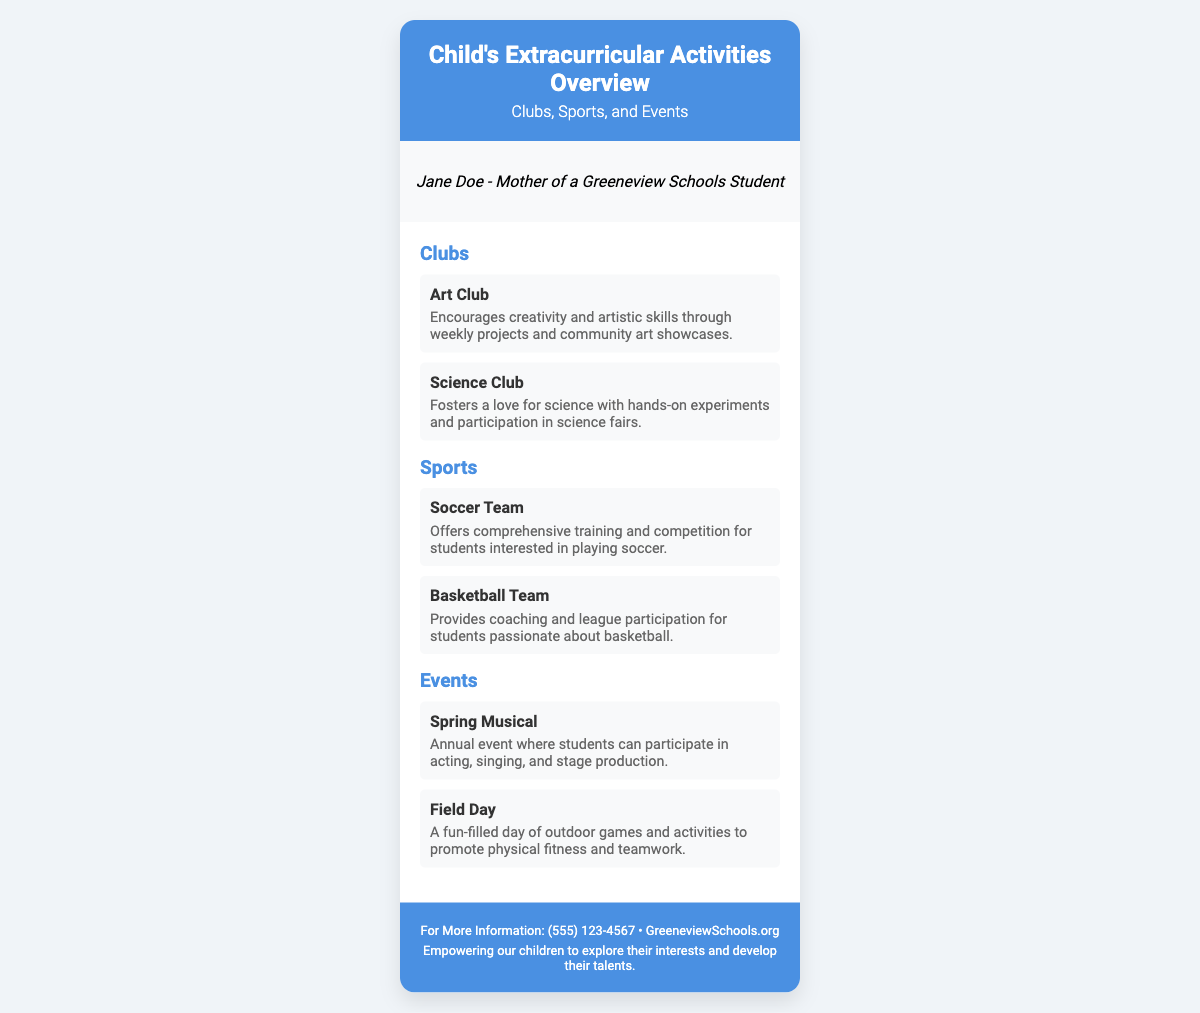What clubs are listed? The clubs mentioned in the document are Art Club and Science Club, which are specified in the Clubs section.
Answer: Art Club, Science Club What sports teams are mentioned? The sports teams listed in the document are found in the Sports section, which includes Soccer Team and Basketball Team.
Answer: Soccer Team, Basketball Team What event occurs annually? The document specifies the Spring Musical as an annual event where students can participate in acting, singing, and stage production.
Answer: Spring Musical How many clubs are featured? The number of clubs is determined by counting the items in the Clubs section, which are Art Club and Science Club.
Answer: 2 What is the phone number provided for more information? The phone number can be found in the footer of the document, which is meant for further inquiries.
Answer: (555) 123-4567 Which event promotes physical fitness? The event promoting physical fitness is Field Day as stated in the Events section, which focuses on outdoor games and activities.
Answer: Field Day Who is the persona on this card? The persona is the name and role mentioned in the document, reflecting the perspective of a parent.
Answer: Jane Doe What type of document is this? The document's title and structure clearly identify it as an overview of a child's extracurricular activities.
Answer: Business card 